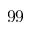Convert formula to latex. <formula><loc_0><loc_0><loc_500><loc_500>9 9</formula> 